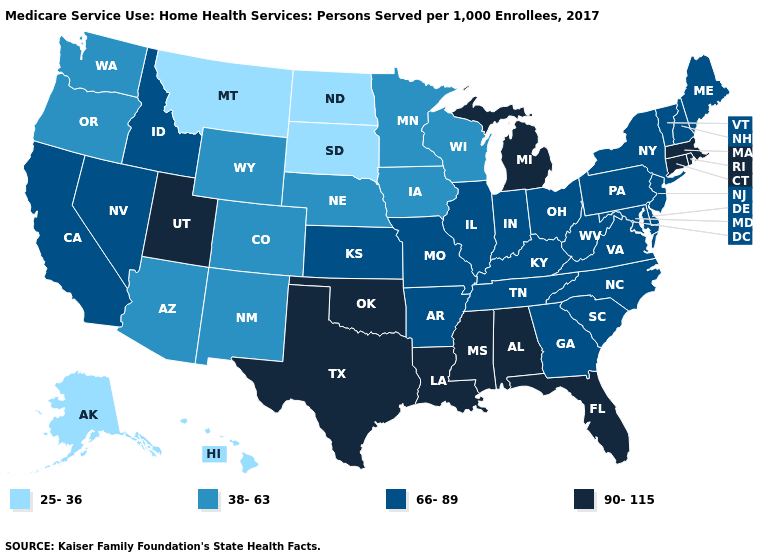What is the lowest value in the USA?
Answer briefly. 25-36. Which states have the lowest value in the USA?
Concise answer only. Alaska, Hawaii, Montana, North Dakota, South Dakota. What is the value of Missouri?
Concise answer only. 66-89. Does Kansas have the highest value in the USA?
Be succinct. No. Among the states that border Utah , which have the lowest value?
Give a very brief answer. Arizona, Colorado, New Mexico, Wyoming. Name the states that have a value in the range 38-63?
Give a very brief answer. Arizona, Colorado, Iowa, Minnesota, Nebraska, New Mexico, Oregon, Washington, Wisconsin, Wyoming. Does Louisiana have the highest value in the USA?
Write a very short answer. Yes. What is the value of Idaho?
Answer briefly. 66-89. What is the highest value in the MidWest ?
Answer briefly. 90-115. Name the states that have a value in the range 25-36?
Be succinct. Alaska, Hawaii, Montana, North Dakota, South Dakota. Among the states that border Arkansas , which have the highest value?
Be succinct. Louisiana, Mississippi, Oklahoma, Texas. Does Virginia have the highest value in the South?
Be succinct. No. Name the states that have a value in the range 66-89?
Answer briefly. Arkansas, California, Delaware, Georgia, Idaho, Illinois, Indiana, Kansas, Kentucky, Maine, Maryland, Missouri, Nevada, New Hampshire, New Jersey, New York, North Carolina, Ohio, Pennsylvania, South Carolina, Tennessee, Vermont, Virginia, West Virginia. Does the map have missing data?
Quick response, please. No. 